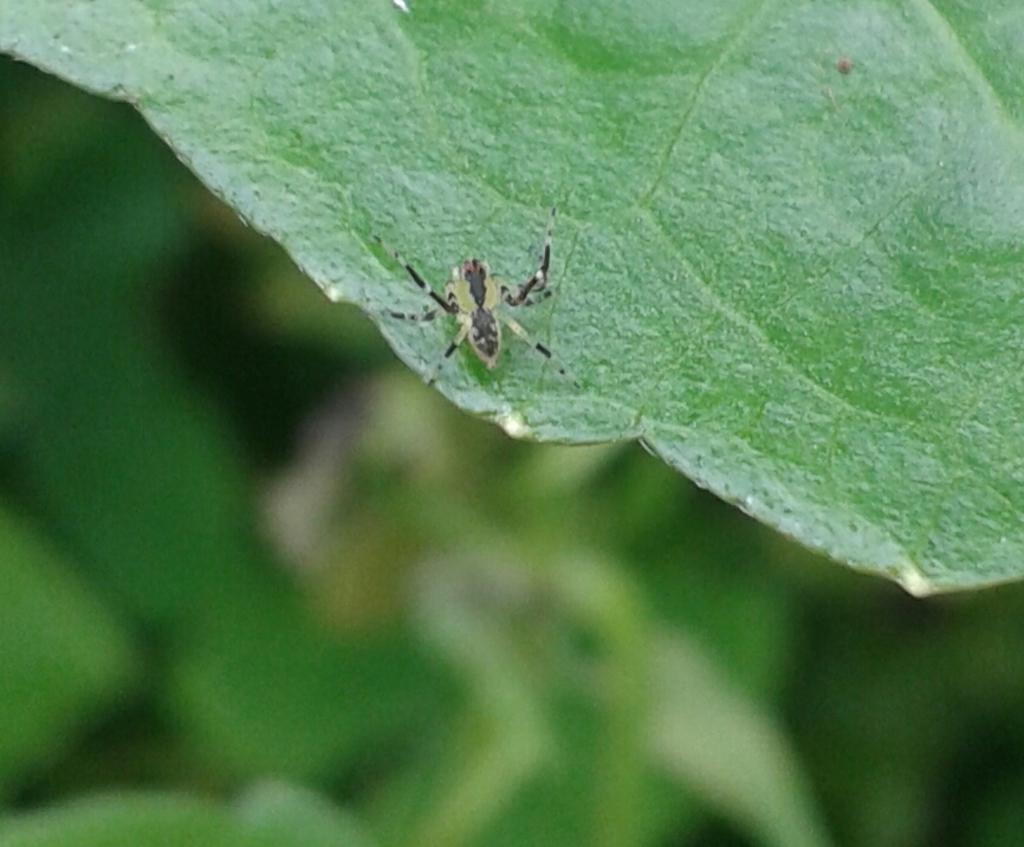What is the main subject of the picture? The main subject of the picture is an insect. Where is the insect located in the image? The insect is on a leaf. Can you describe the background of the image? The background of the image is blurry. What type of salt can be seen on the train tracks in the image? There is no salt or train tracks present in the image; it features an insect on a leaf with a blurry background. 